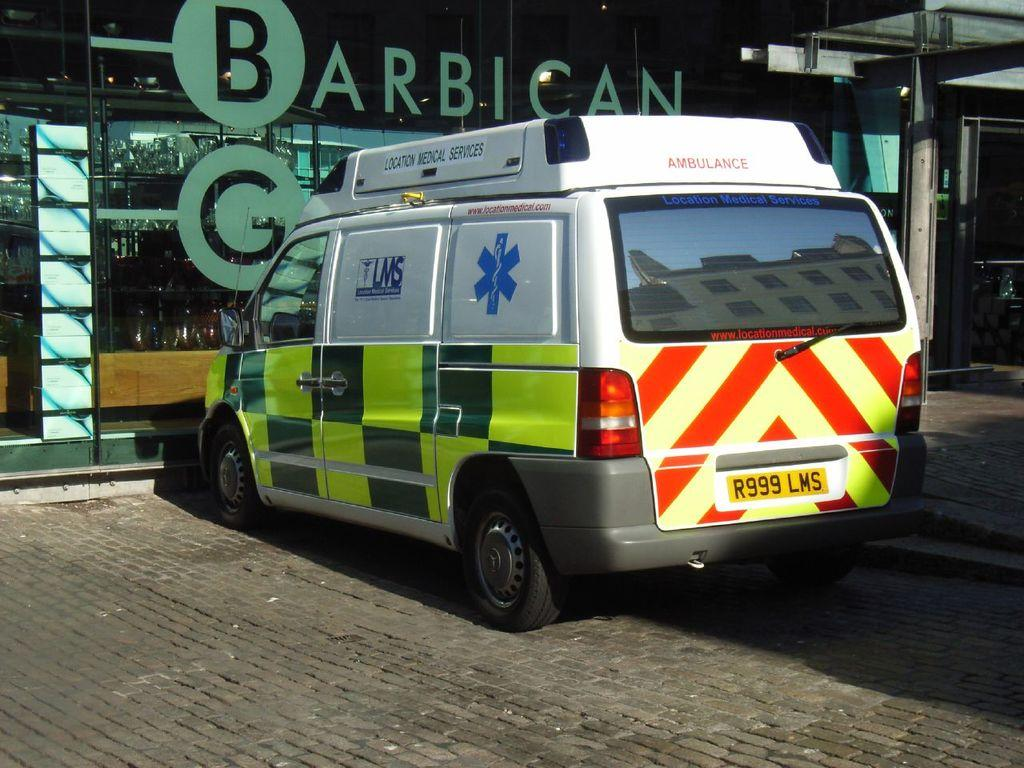What is the main subject of the image? The main subject of the image is an ambulance. Where is the ambulance located in the image? The ambulance is parked near a building. Can you describe any other features in the image? There is a door visible on the right side of the image. How many chairs can be seen in the image? There are no chairs present in the image. What type of wind can be felt in the image? There is no indication of wind in the image, as it is a still photograph. 